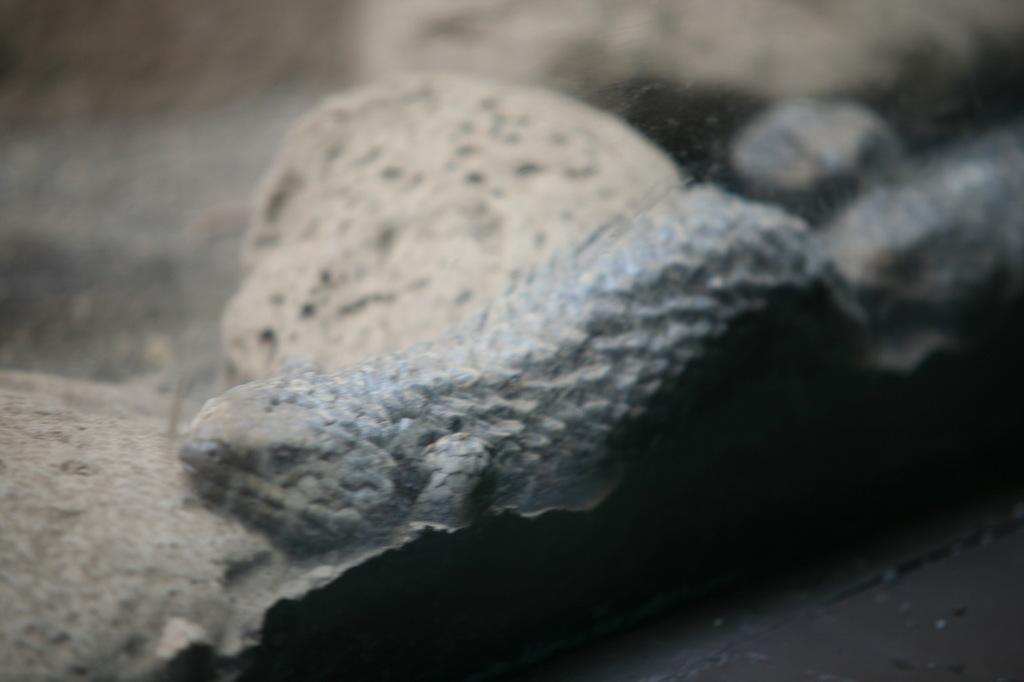How would you summarize this image in a sentence or two? In this image, we can see a reptile. Background it is a blur view. 